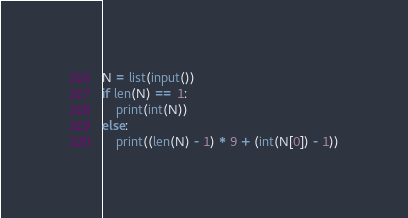Convert code to text. <code><loc_0><loc_0><loc_500><loc_500><_Python_>N = list(input())
if len(N) == 1:
    print(int(N))
else:
    print((len(N) - 1) * 9 + (int(N[0]) - 1))
</code> 